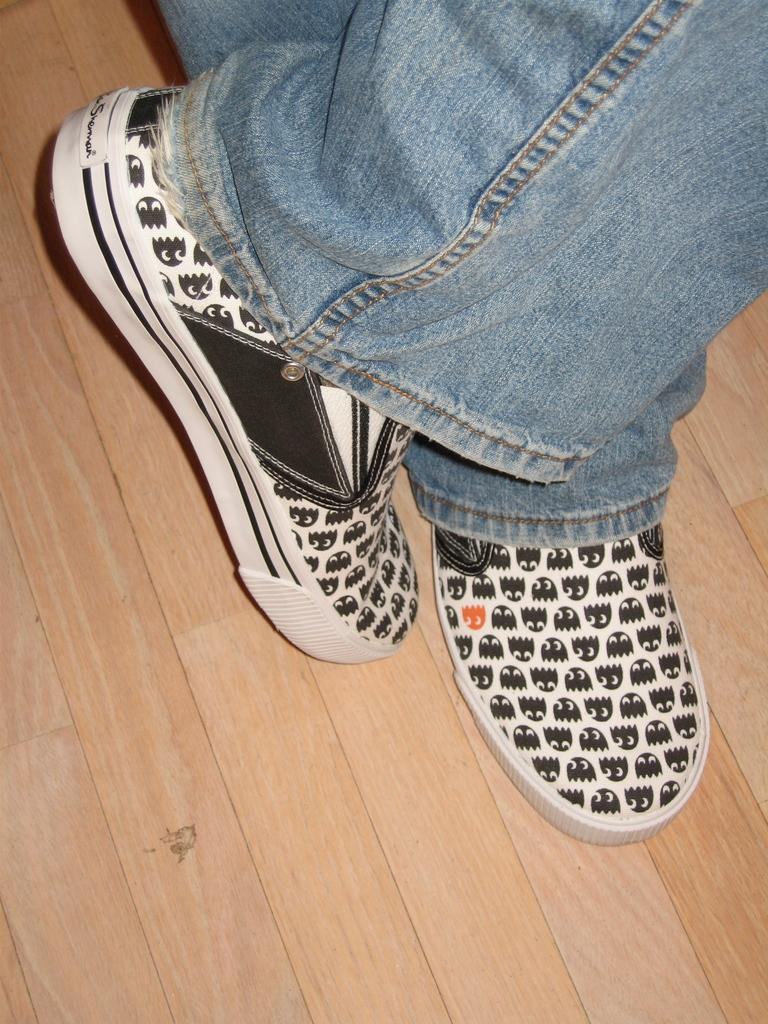Who or what is the main subject in the image? There is a person in the image. What part of the person's body is visible in the foreground? The person's legs are visible in the foreground. What type of clothing is the person wearing on their legs? The person is wearing blue jeans. What type of shoes is the person wearing? The person is wearing white and black shoes. What type of stamp can be seen on the person's jeans in the image? There is no stamp visible on the person's jeans in the image. 